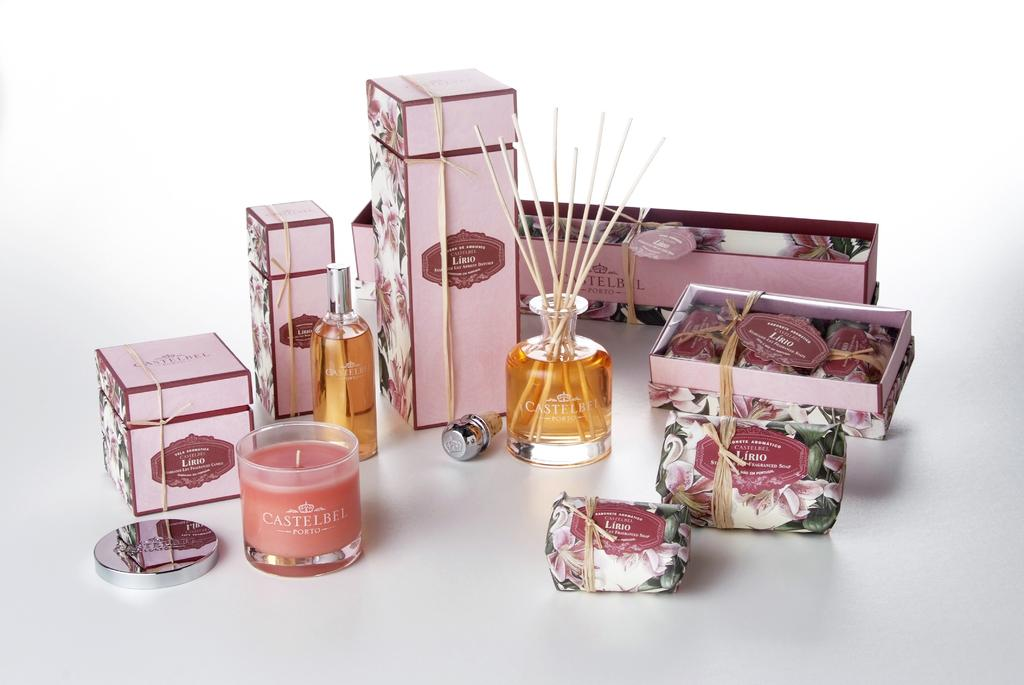<image>
Share a concise interpretation of the image provided. Various gift packaging for Castelbel scented soaps and candles. 